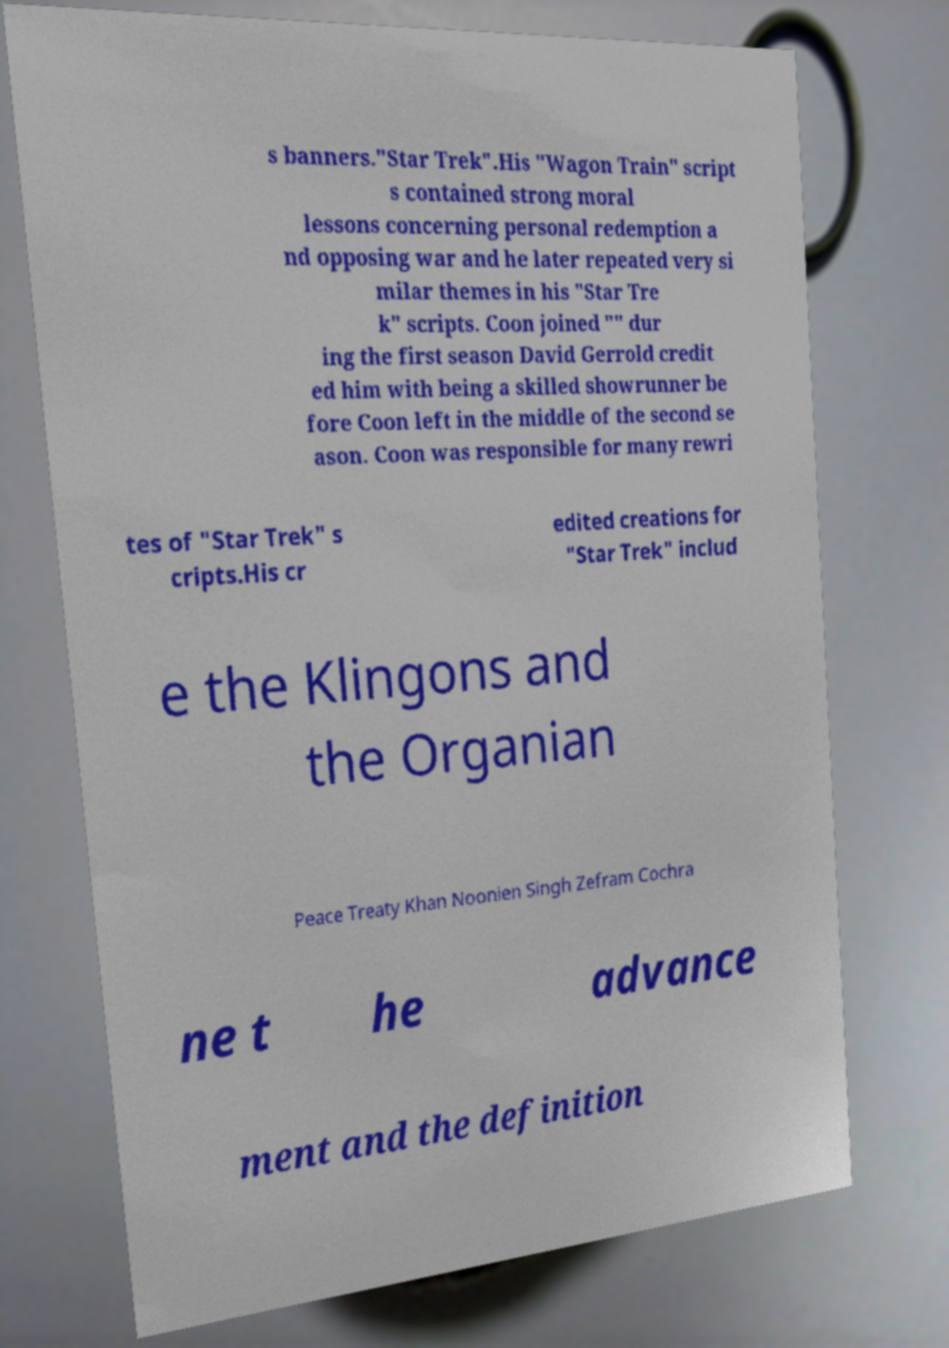Can you read and provide the text displayed in the image?This photo seems to have some interesting text. Can you extract and type it out for me? s banners."Star Trek".His "Wagon Train" script s contained strong moral lessons concerning personal redemption a nd opposing war and he later repeated very si milar themes in his "Star Tre k" scripts. Coon joined "" dur ing the first season David Gerrold credit ed him with being a skilled showrunner be fore Coon left in the middle of the second se ason. Coon was responsible for many rewri tes of "Star Trek" s cripts.His cr edited creations for "Star Trek" includ e the Klingons and the Organian Peace Treaty Khan Noonien Singh Zefram Cochra ne t he advance ment and the definition 